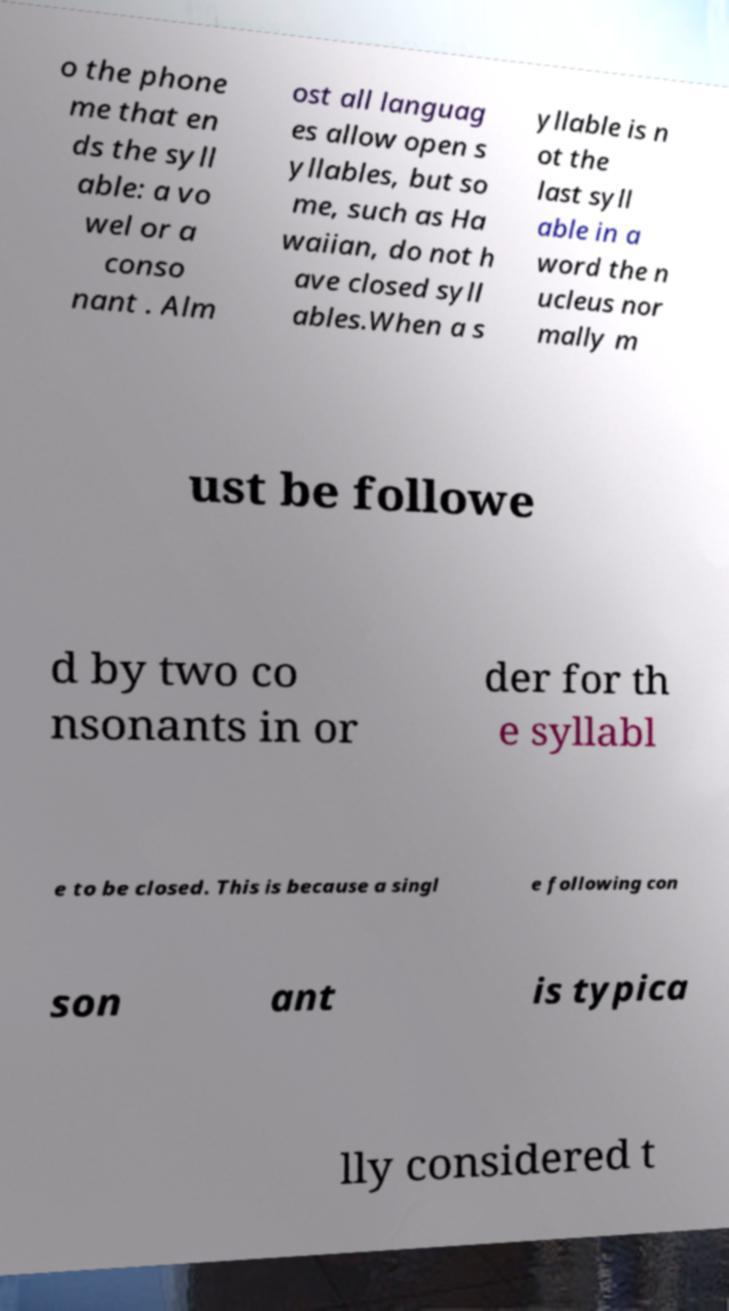For documentation purposes, I need the text within this image transcribed. Could you provide that? o the phone me that en ds the syll able: a vo wel or a conso nant . Alm ost all languag es allow open s yllables, but so me, such as Ha waiian, do not h ave closed syll ables.When a s yllable is n ot the last syll able in a word the n ucleus nor mally m ust be followe d by two co nsonants in or der for th e syllabl e to be closed. This is because a singl e following con son ant is typica lly considered t 